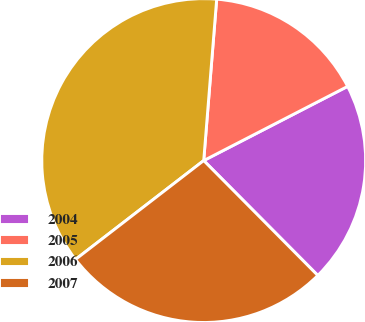Convert chart to OTSL. <chart><loc_0><loc_0><loc_500><loc_500><pie_chart><fcel>2004<fcel>2005<fcel>2006<fcel>2007<nl><fcel>20.13%<fcel>16.15%<fcel>36.73%<fcel>26.99%<nl></chart> 